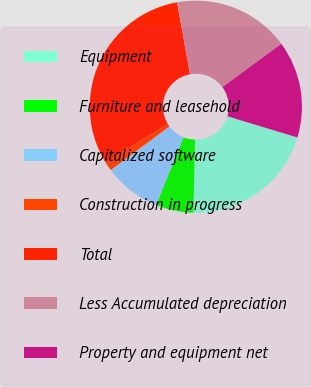Convert chart. <chart><loc_0><loc_0><loc_500><loc_500><pie_chart><fcel>Equipment<fcel>Furniture and leasehold<fcel>Capitalized software<fcel>Construction in progress<fcel>Total<fcel>Less Accumulated depreciation<fcel>Property and equipment net<nl><fcel>20.69%<fcel>5.74%<fcel>8.7%<fcel>1.4%<fcel>30.95%<fcel>17.73%<fcel>14.78%<nl></chart> 